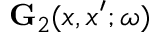Convert formula to latex. <formula><loc_0><loc_0><loc_500><loc_500>{ G } _ { 2 } ( x , x ^ { \prime } ; \omega )</formula> 